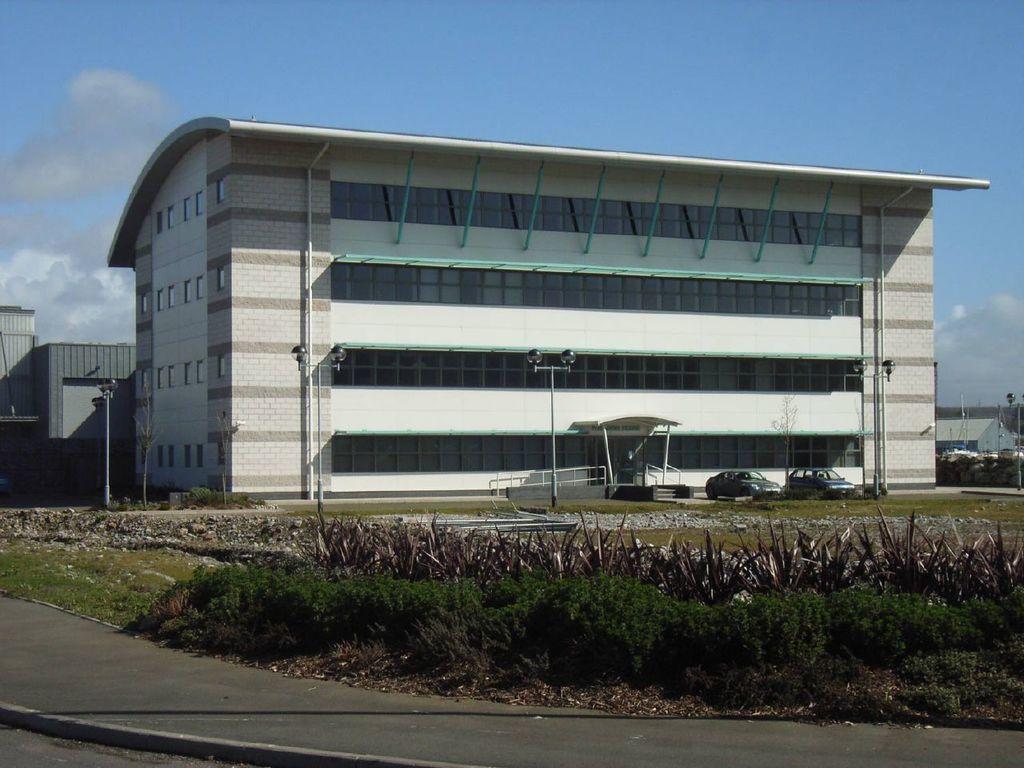How would you summarize this image in a sentence or two? In the foreground of the picture, there is road and few plants. In the background, there are poles, few vehicles, buildings, sky and the cloud. 